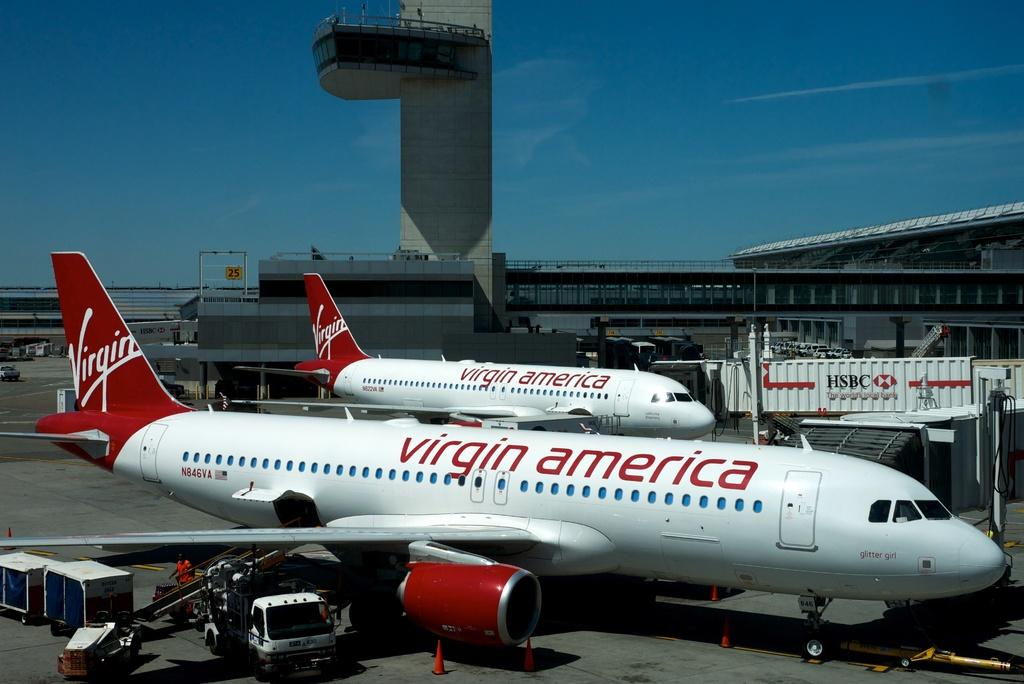<image>
Offer a succinct explanation of the picture presented. Two virgin American planes side by side on the tarmac 